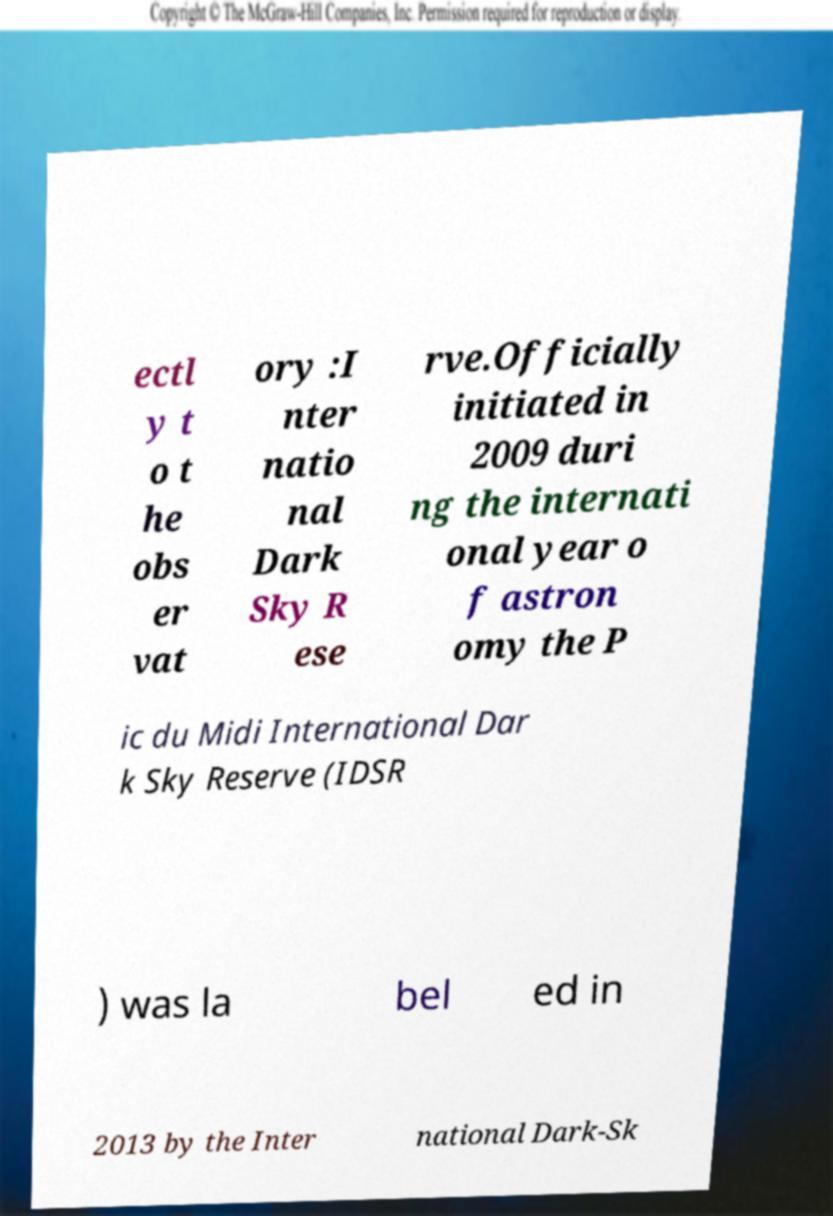Please read and relay the text visible in this image. What does it say? ectl y t o t he obs er vat ory :I nter natio nal Dark Sky R ese rve.Officially initiated in 2009 duri ng the internati onal year o f astron omy the P ic du Midi International Dar k Sky Reserve (IDSR ) was la bel ed in 2013 by the Inter national Dark-Sk 